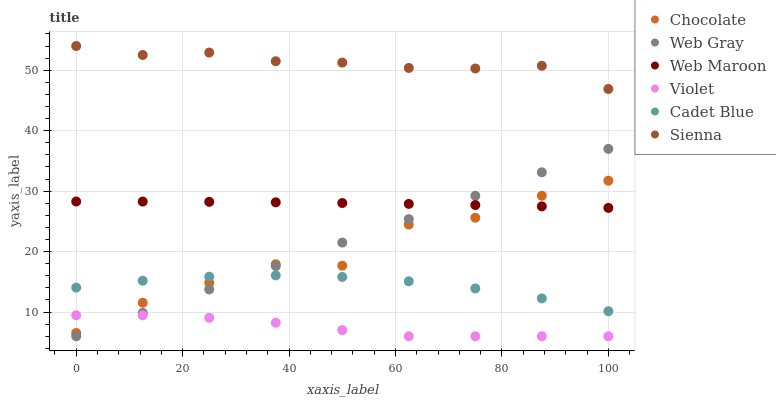Does Violet have the minimum area under the curve?
Answer yes or no. Yes. Does Sienna have the maximum area under the curve?
Answer yes or no. Yes. Does Web Maroon have the minimum area under the curve?
Answer yes or no. No. Does Web Maroon have the maximum area under the curve?
Answer yes or no. No. Is Web Gray the smoothest?
Answer yes or no. Yes. Is Chocolate the roughest?
Answer yes or no. Yes. Is Web Maroon the smoothest?
Answer yes or no. No. Is Web Maroon the roughest?
Answer yes or no. No. Does Web Gray have the lowest value?
Answer yes or no. Yes. Does Web Maroon have the lowest value?
Answer yes or no. No. Does Sienna have the highest value?
Answer yes or no. Yes. Does Web Maroon have the highest value?
Answer yes or no. No. Is Cadet Blue less than Sienna?
Answer yes or no. Yes. Is Web Maroon greater than Violet?
Answer yes or no. Yes. Does Violet intersect Chocolate?
Answer yes or no. Yes. Is Violet less than Chocolate?
Answer yes or no. No. Is Violet greater than Chocolate?
Answer yes or no. No. Does Cadet Blue intersect Sienna?
Answer yes or no. No. 